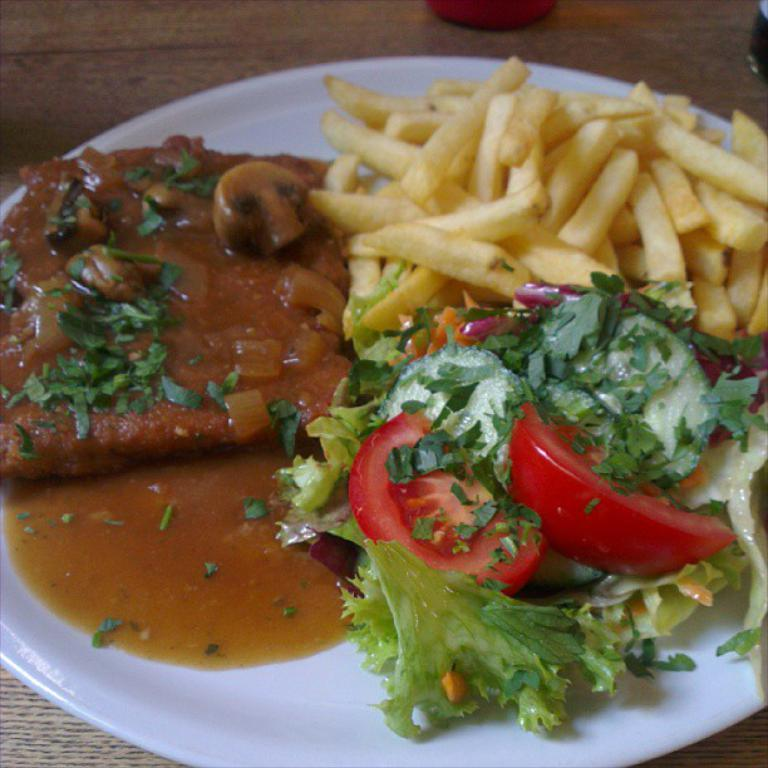What color is the plate that is visible in the image? The plate in the image is white. What is on the plate in the image? There are food items on the plate in the image. Can you see a turkey begging for food waste in the image? No, there is no turkey or food waste present in the image. 